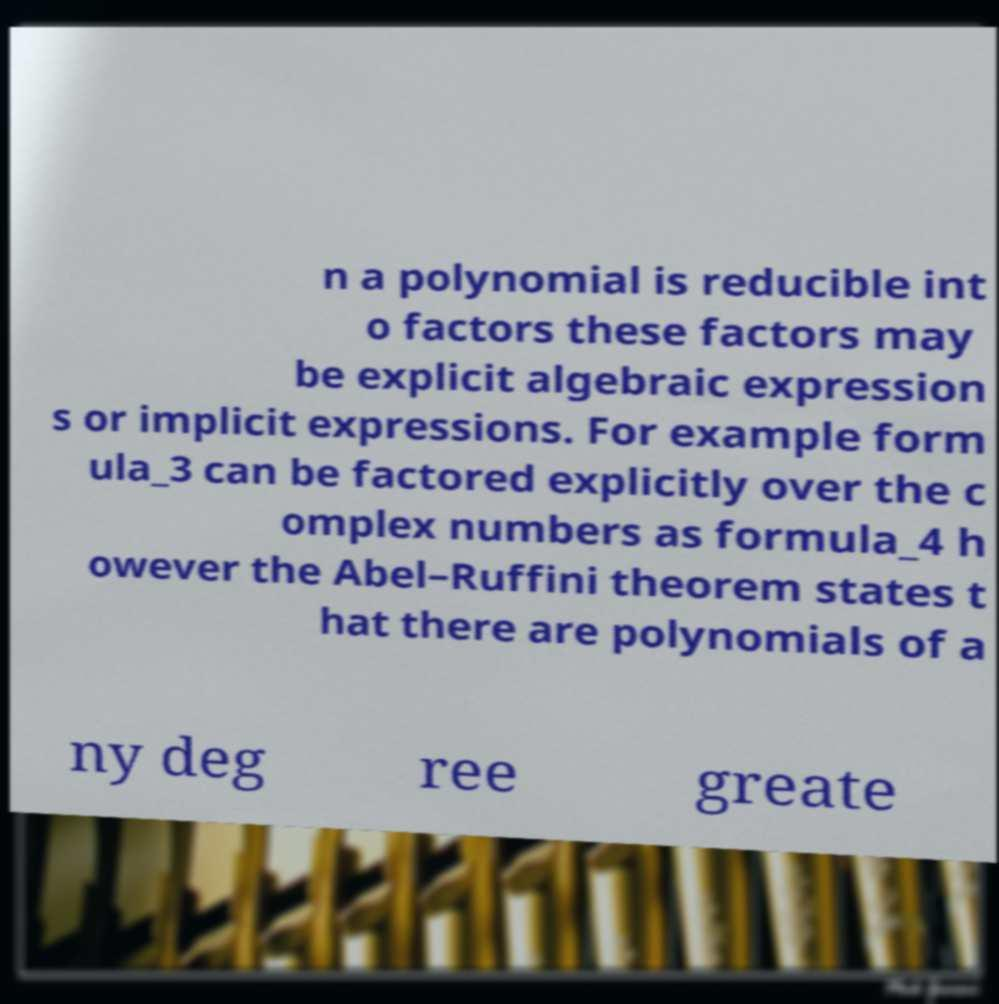Please read and relay the text visible in this image. What does it say? n a polynomial is reducible int o factors these factors may be explicit algebraic expression s or implicit expressions. For example form ula_3 can be factored explicitly over the c omplex numbers as formula_4 h owever the Abel–Ruffini theorem states t hat there are polynomials of a ny deg ree greate 